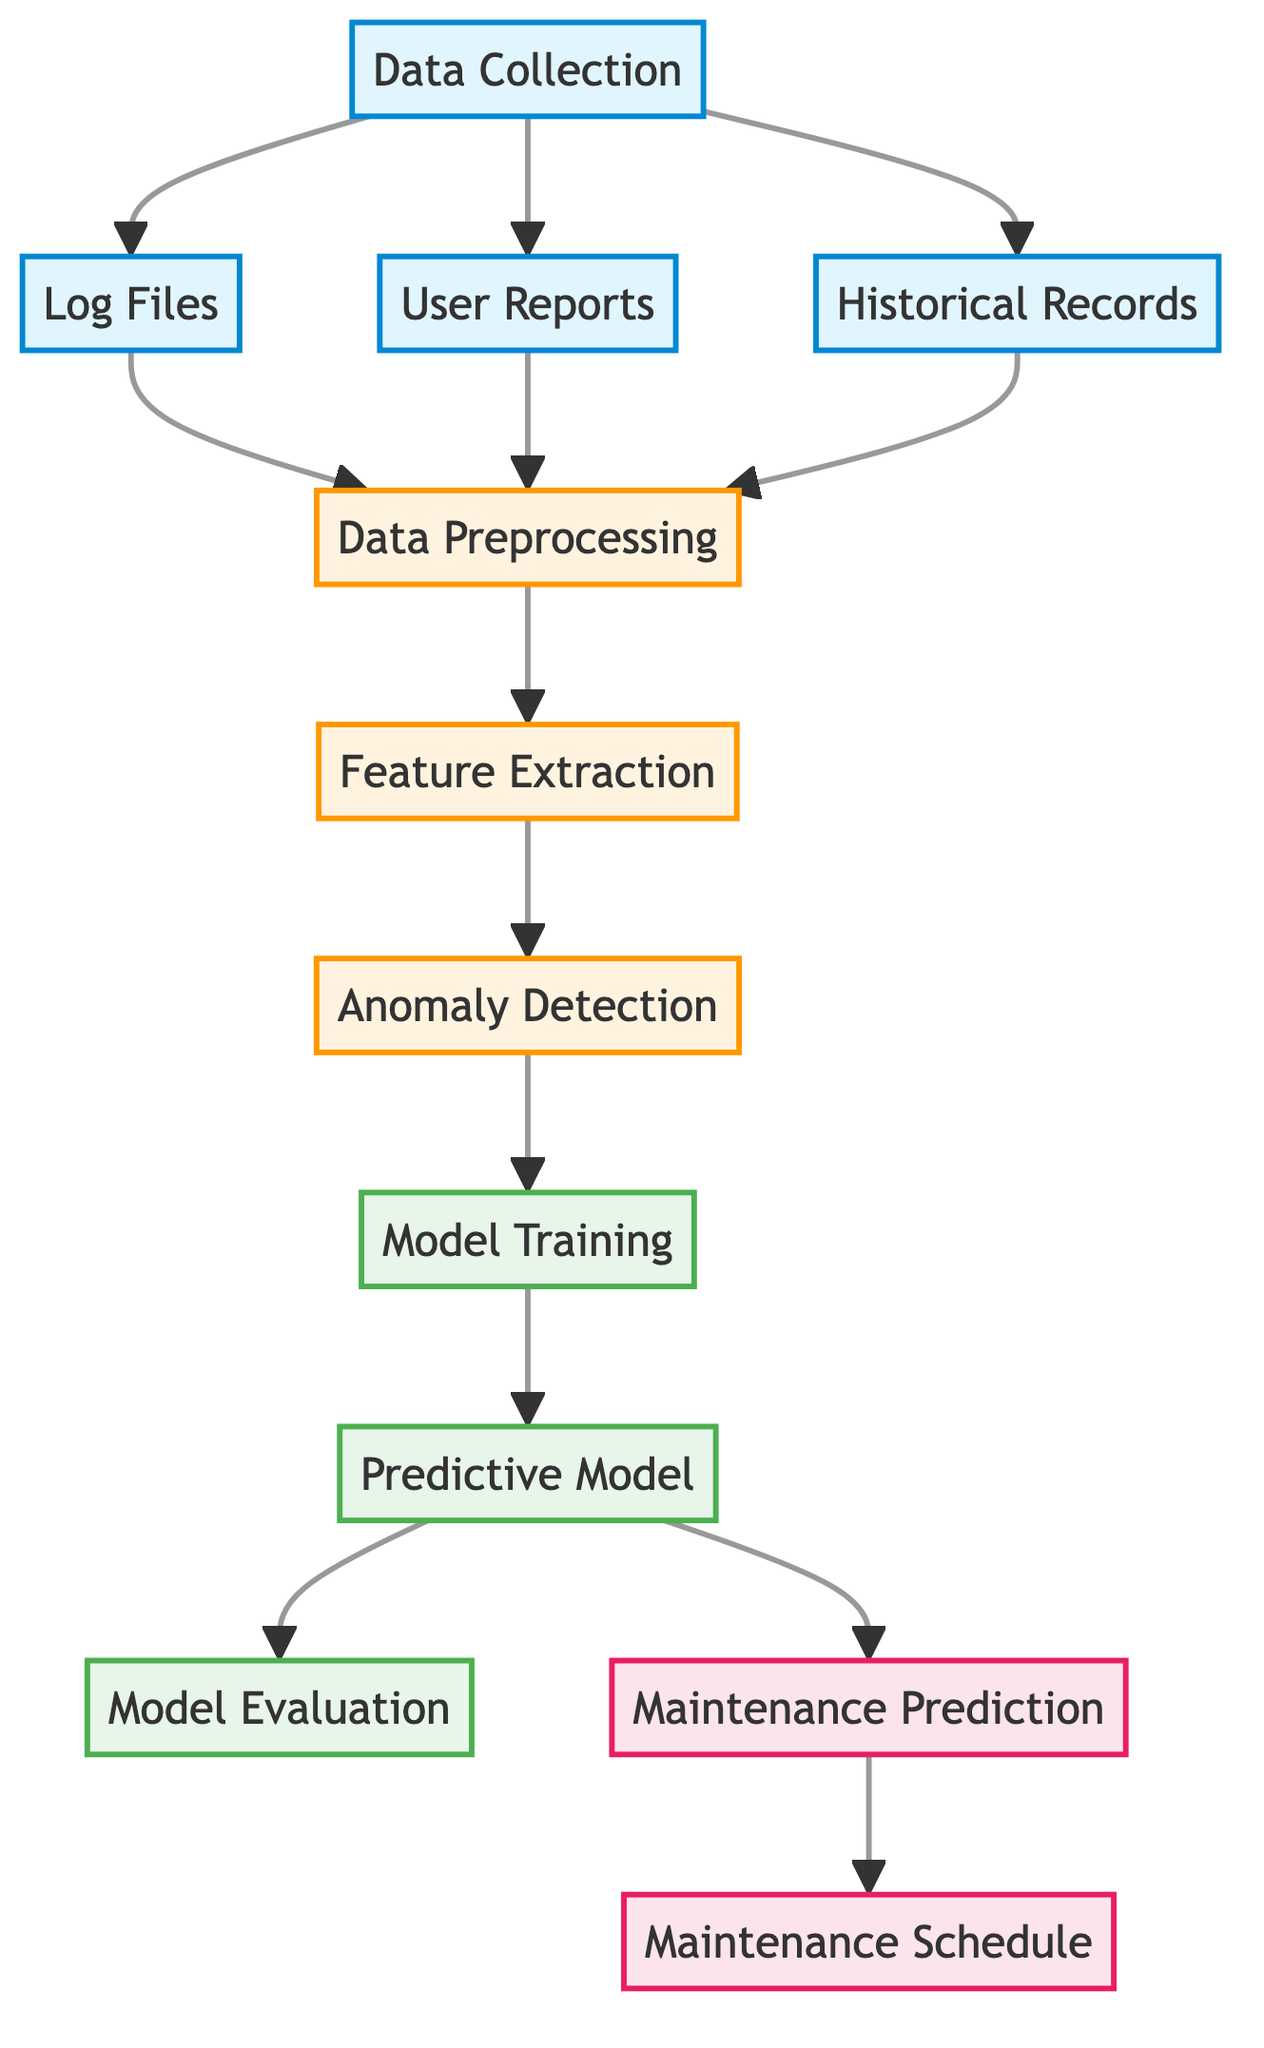What are the three sources of data collection? The nodes labeled "Log Files," "User Reports," and "Historical Records" are clearly identified in the diagram as the primary sources of data collection.
Answer: Log Files, User Reports, Historical Records How many processing steps are shown in the diagram? The nodes for processing are "Data Preprocessing," "Feature Extraction," and "Anomaly Detection," totaling three steps that move sequentially from data collection to the model training process.
Answer: 3 What is the final output of the predictive model? The final two outputs identified in the diagram are "Maintenance Prediction" and "Maintenance Schedule," which reflect the predicted maintenance activities based on model outputs.
Answer: Maintenance Prediction, Maintenance Schedule Which node directly follows feature extraction? The diagram shows an arrow that connects "Feature Extraction" to "Anomaly Detection," indicating that anomaly detection is the subsequent step that takes place after feature extraction.
Answer: Anomaly Detection What is the purpose of the model training node? The model training node indicates that it plays a critical role in developing the predictive model using the processed features and detected anomalies as input data for training.
Answer: To develop the predictive model Which node receives data from anomaly detection? The arrow leading from "Anomaly Detection" clearly demonstrates that "Model Training" is the next node affected by the results from the anomaly detection process, which is crucial for advancing the predictive model.
Answer: Model Training How does data preprocessing connect to feature extraction? The connection between "Data Preprocessing" and "Feature Extraction" is depicted by a directed arrow indicating that it serves as a direct pathway in the data pipeline from preprocessing to the feature extraction stage.
Answer: Direct pathway How many nodes are in the model stage? The diagram identifies three nodes specifically in the model stage: "Predictive Model," "Model Training," and "Model Evaluation," which collectively represent critical elements in building the machine learning model.
Answer: 3 